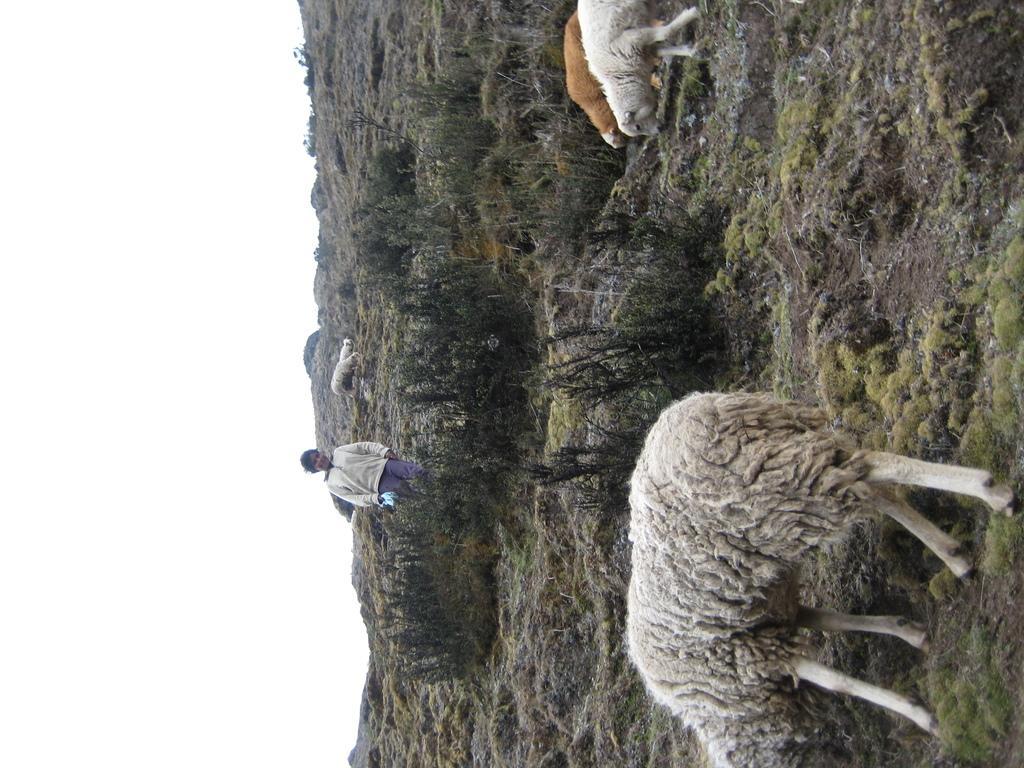Please provide a concise description of this image. In this image I see a person over here and I see the sheeps and I see the grass and the plants. In the background I see the clear sky. 